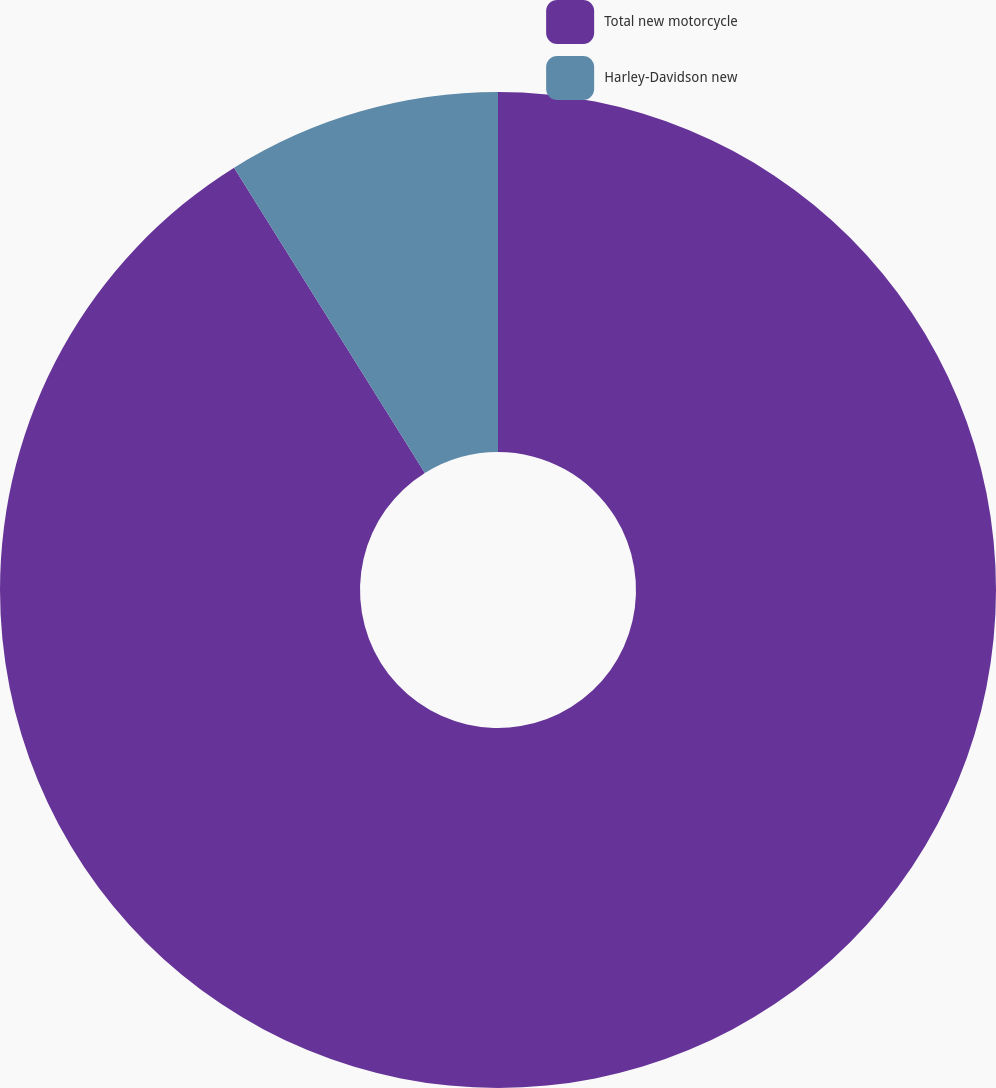Convert chart. <chart><loc_0><loc_0><loc_500><loc_500><pie_chart><fcel>Total new motorcycle<fcel>Harley-Davidson new<nl><fcel>91.11%<fcel>8.89%<nl></chart> 